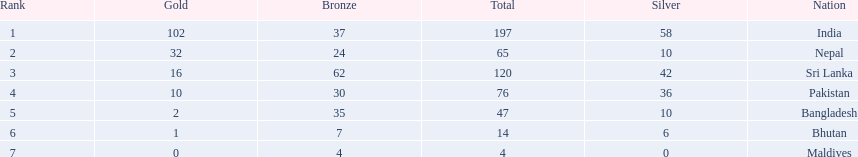What were the total amount won of medals by nations in the 1999 south asian games? 197, 65, 120, 76, 47, 14, 4. Which amount was the lowest? 4. Which nation had this amount? Maldives. 